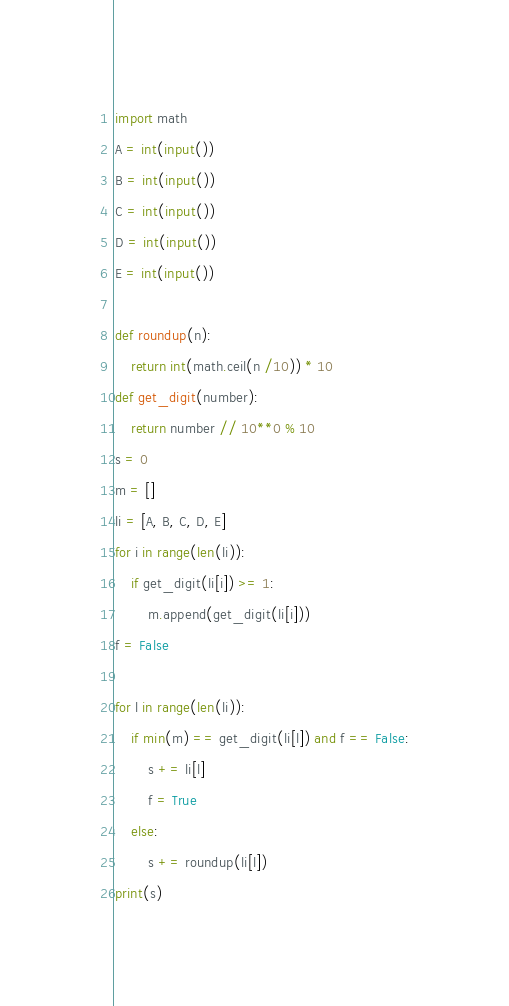Convert code to text. <code><loc_0><loc_0><loc_500><loc_500><_Python_>import math
A = int(input())
B = int(input())
C = int(input())
D = int(input())
E = int(input())

def roundup(n):
    return int(math.ceil(n /10)) * 10
def get_digit(number):
    return number // 10**0 % 10   
s = 0
m = []
li = [A, B, C, D, E]
for i in range(len(li)):
    if get_digit(li[i]) >= 1:
        m.append(get_digit(li[i]))
f = False
        
for l in range(len(li)):
    if min(m) == get_digit(li[l]) and f == False:
        s += li[l]
        f = True
    else:
        s += roundup(li[l])
print(s)</code> 